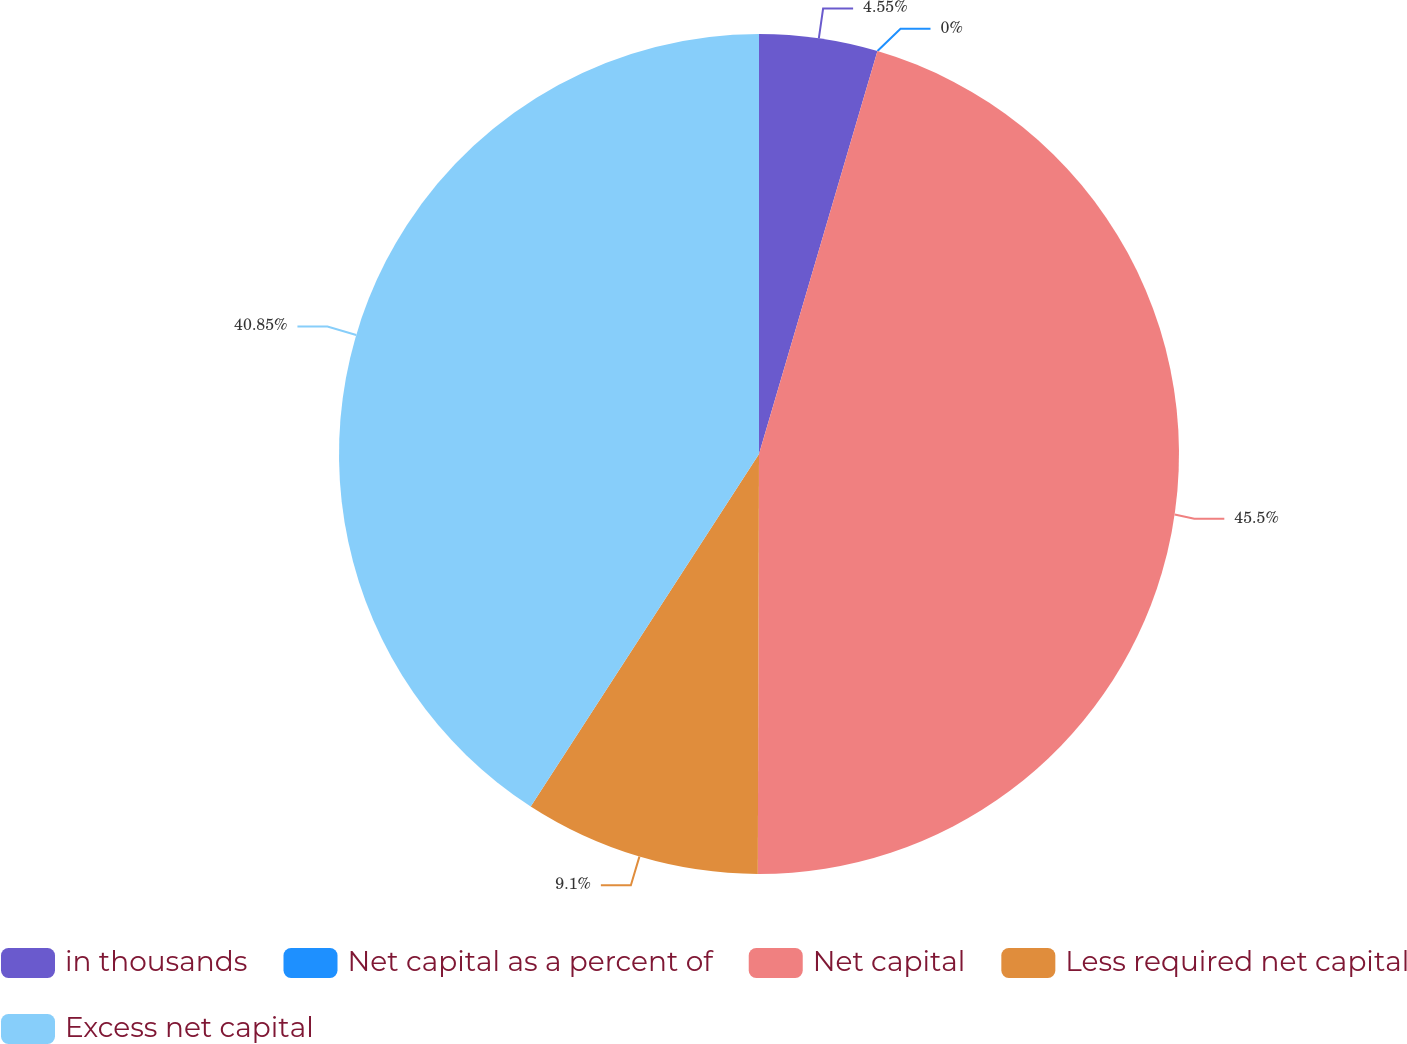<chart> <loc_0><loc_0><loc_500><loc_500><pie_chart><fcel>in thousands<fcel>Net capital as a percent of<fcel>Net capital<fcel>Less required net capital<fcel>Excess net capital<nl><fcel>4.55%<fcel>0.0%<fcel>45.49%<fcel>9.1%<fcel>40.85%<nl></chart> 